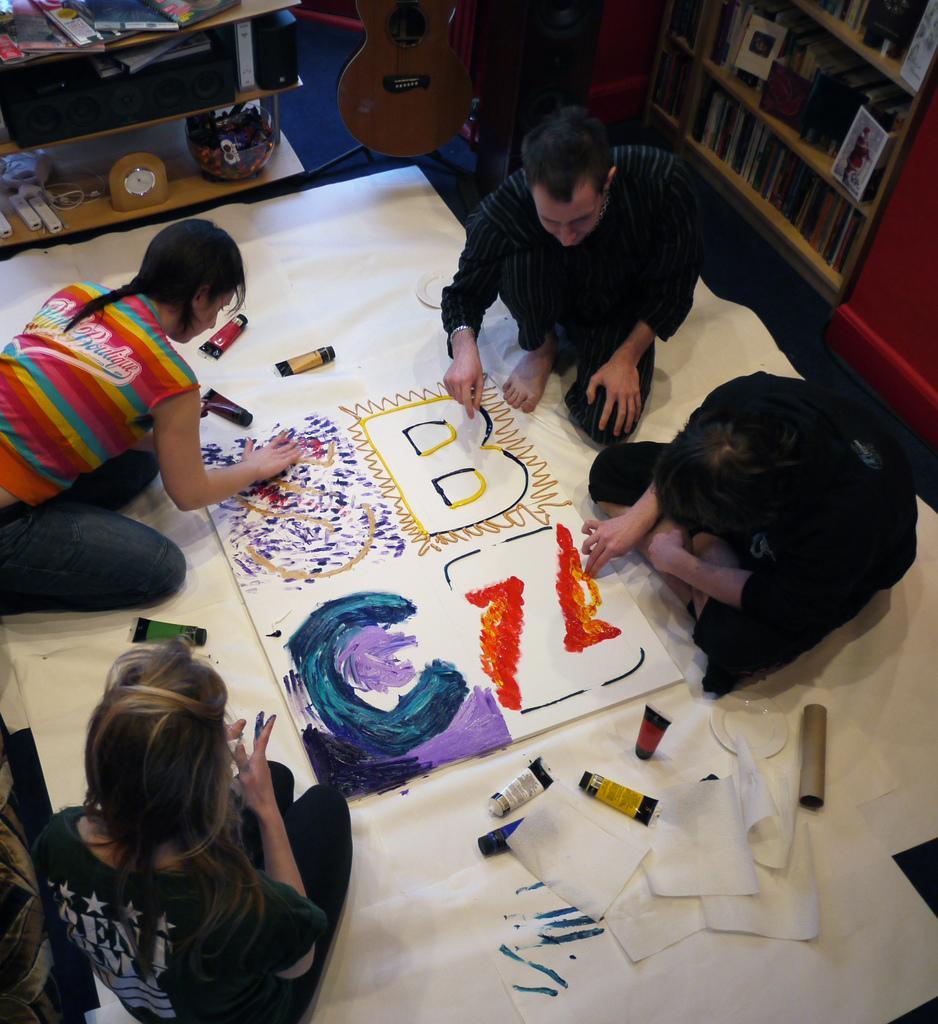Can you describe this image briefly? In this image there are people on the floor. There is a board, papers and few objects on the floor. People are painting on the board. Top of the image there is a guitar. Beside there is a rack having books and few objects. Right side there is a rack having books and few objects. 